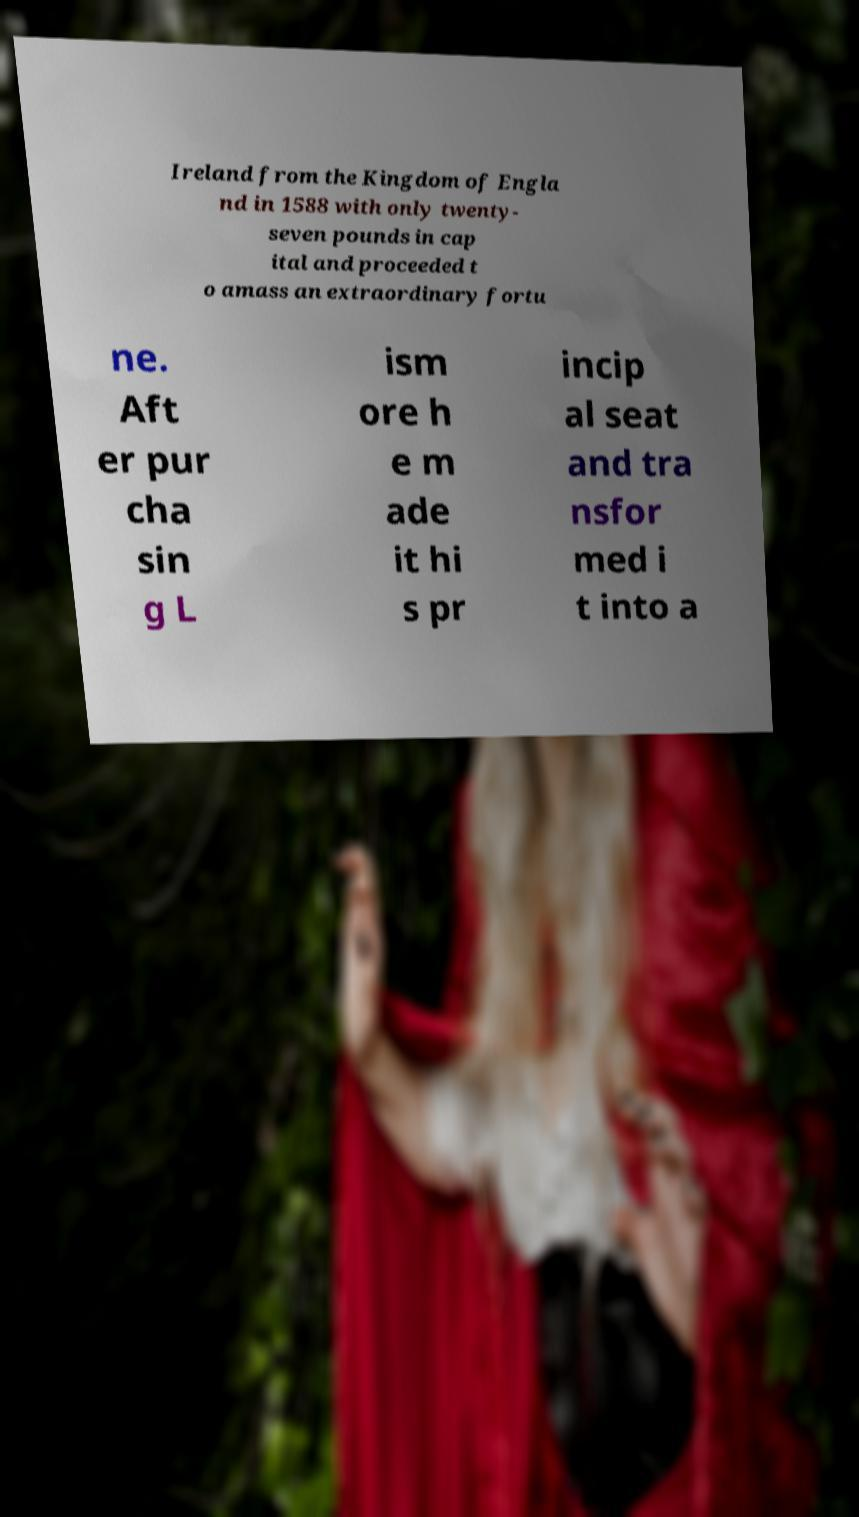Can you accurately transcribe the text from the provided image for me? Ireland from the Kingdom of Engla nd in 1588 with only twenty- seven pounds in cap ital and proceeded t o amass an extraordinary fortu ne. Aft er pur cha sin g L ism ore h e m ade it hi s pr incip al seat and tra nsfor med i t into a 